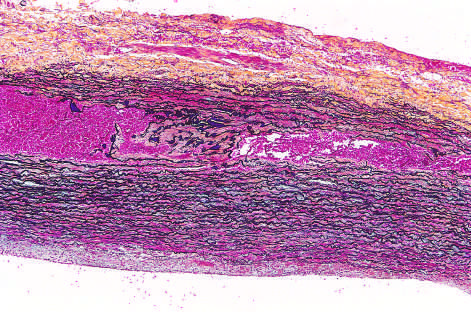where is red blood, stained with movat stain?
Answer the question using a single word or phrase. In this section 